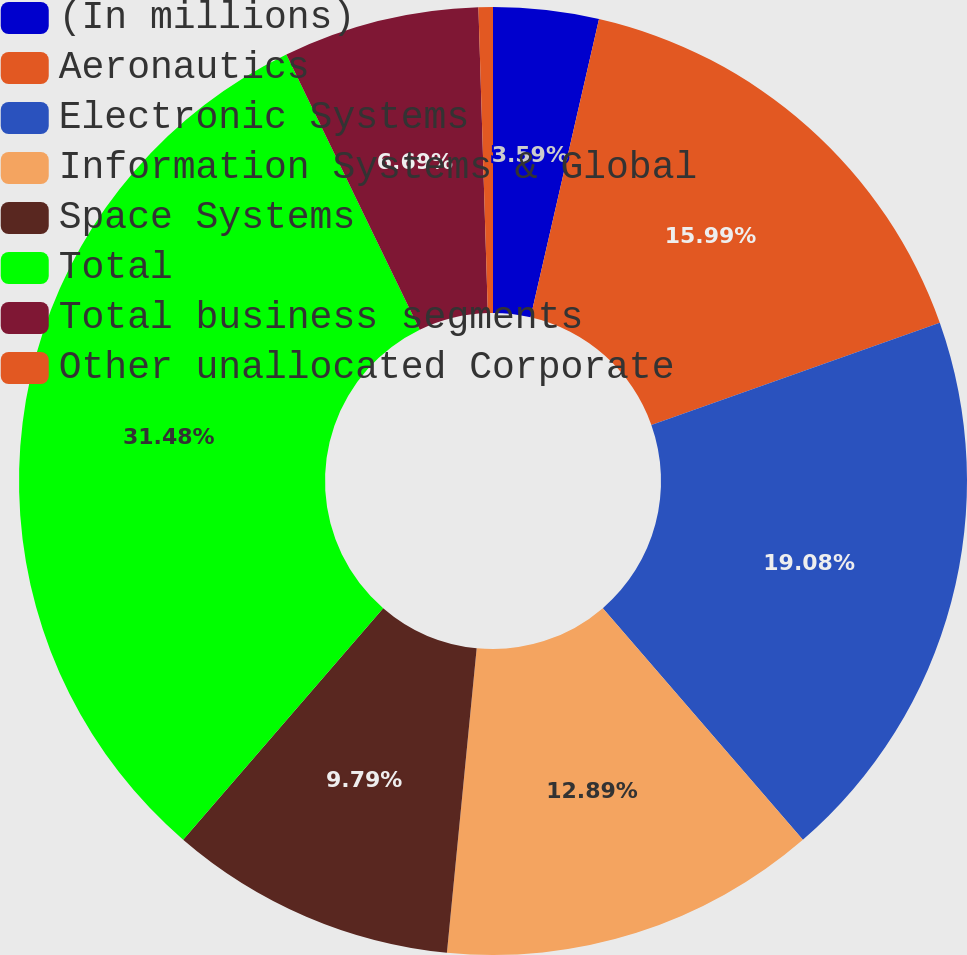<chart> <loc_0><loc_0><loc_500><loc_500><pie_chart><fcel>(In millions)<fcel>Aeronautics<fcel>Electronic Systems<fcel>Information Systems & Global<fcel>Space Systems<fcel>Total<fcel>Total business segments<fcel>Other unallocated Corporate<nl><fcel>3.59%<fcel>15.99%<fcel>19.08%<fcel>12.89%<fcel>9.79%<fcel>31.48%<fcel>6.69%<fcel>0.49%<nl></chart> 